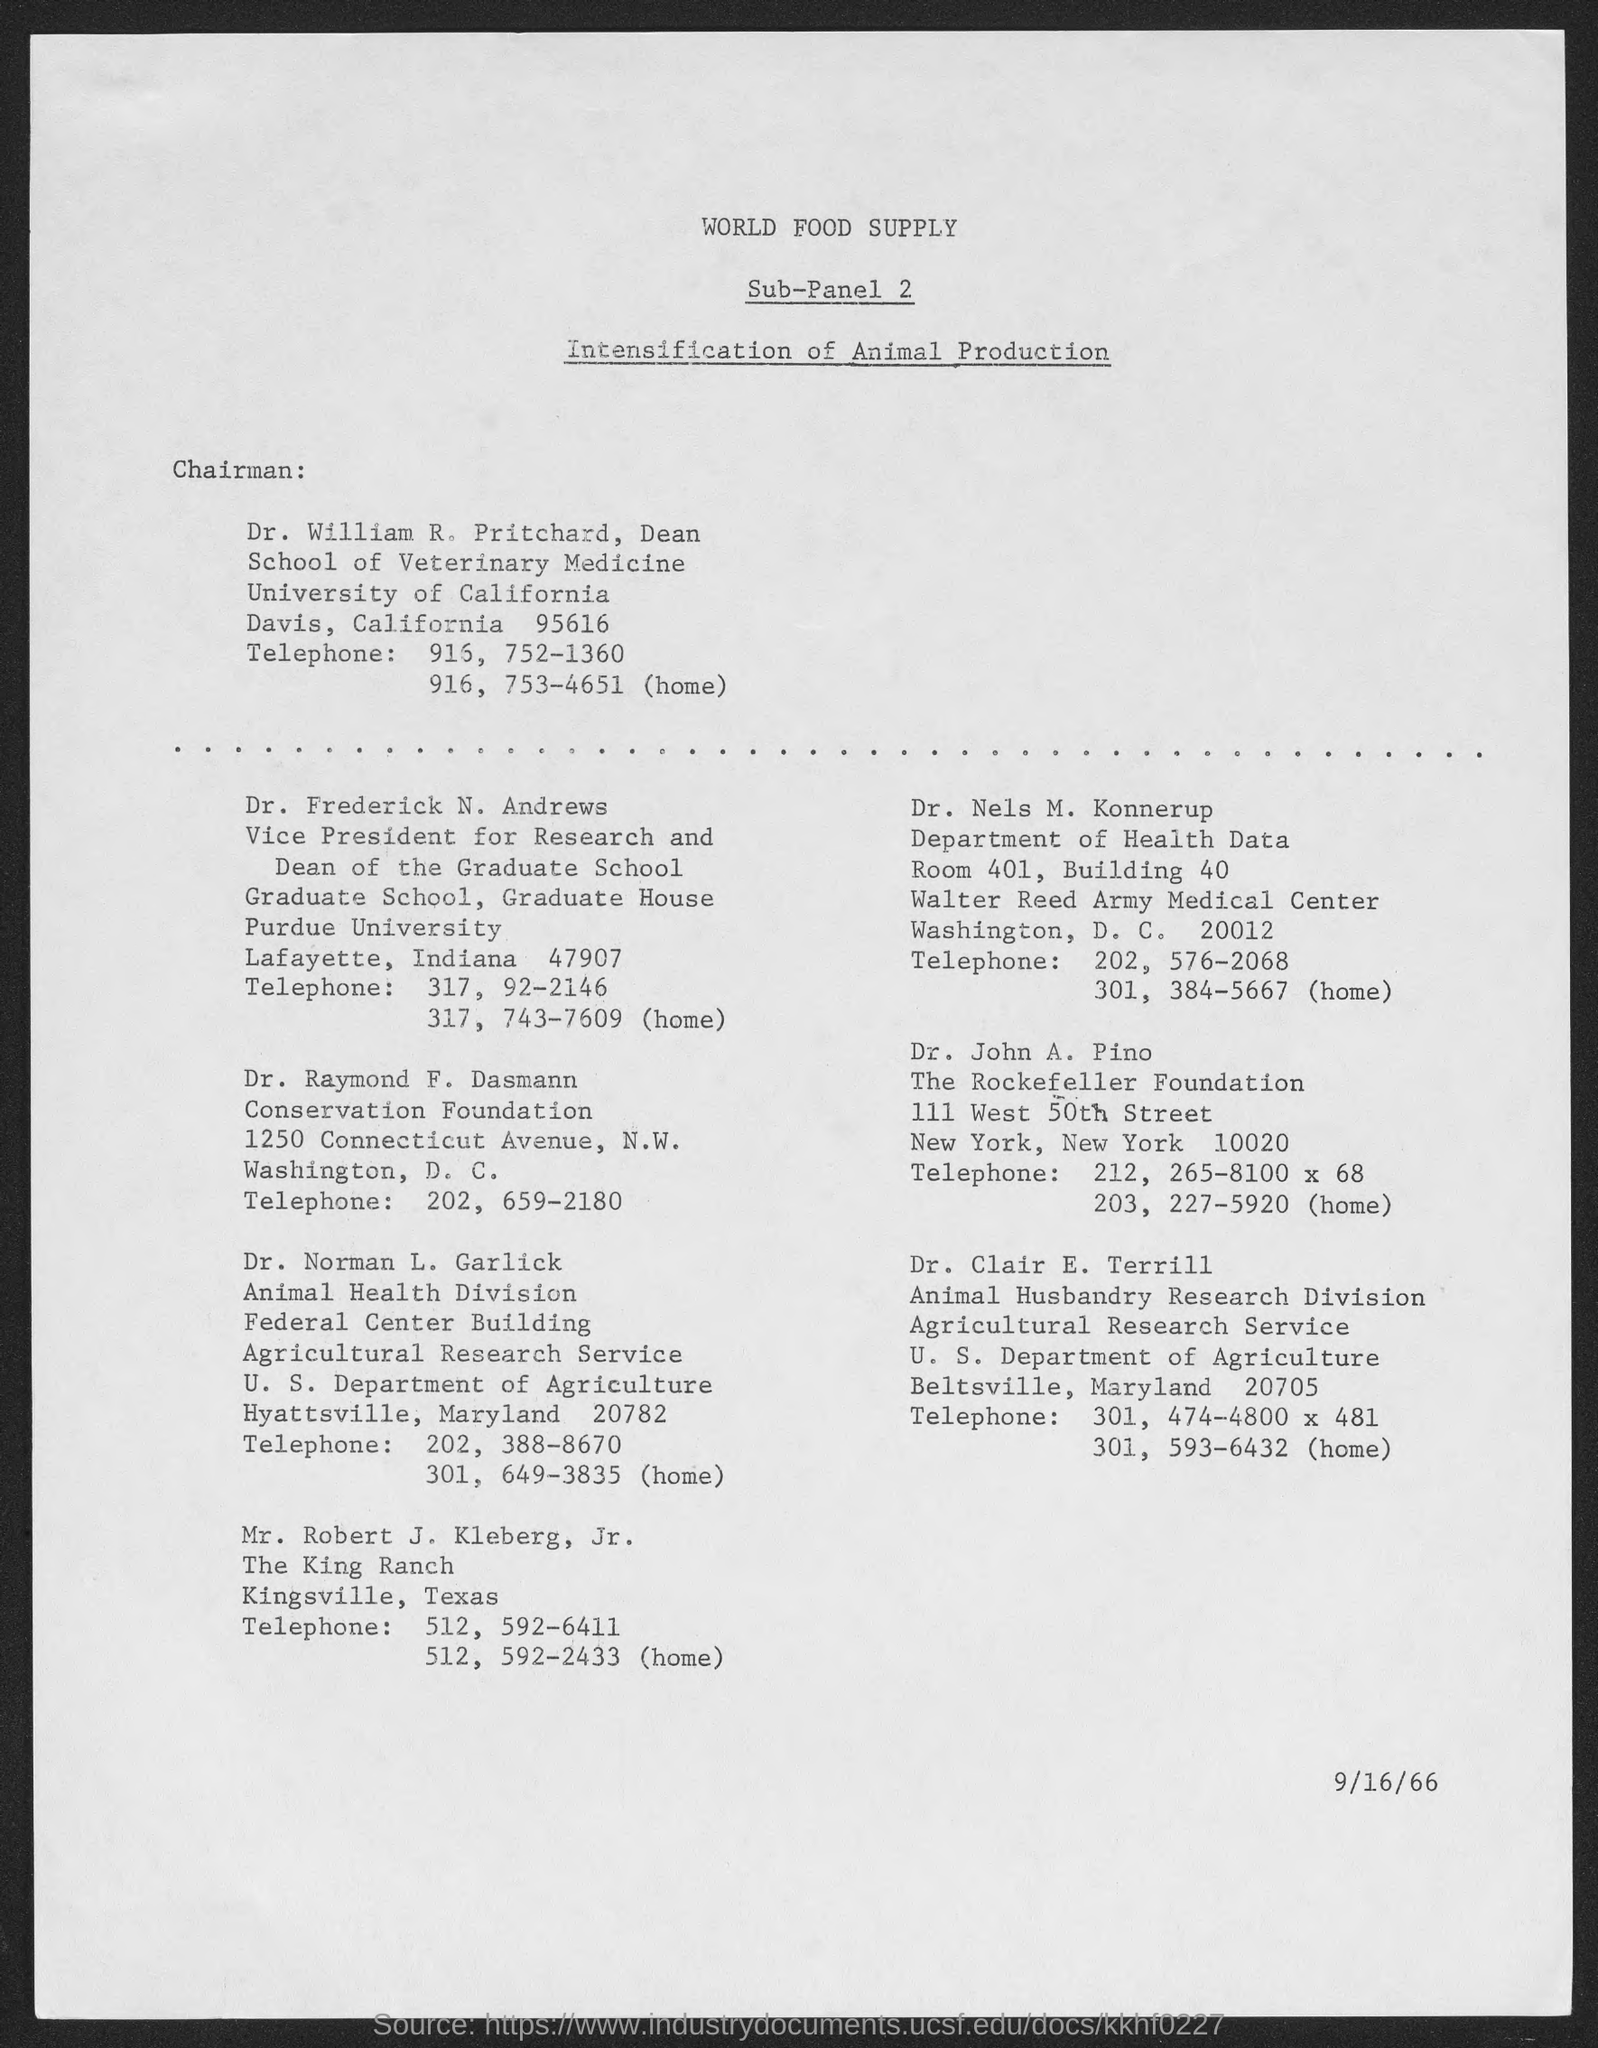Identify some key points in this picture. Dr. William R. Pritchard is a member of the University of California. The date at the bottom of the page is September 16, 1966. 